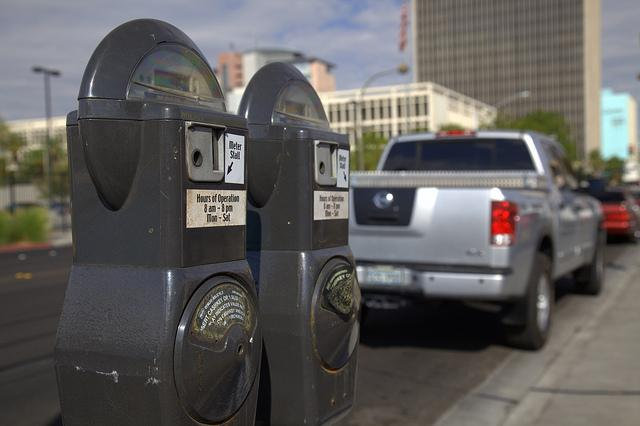What is the purpose of the object?

Choices:
A) call police
B) call ambulance
C) help you
D) provide parking provide parking 